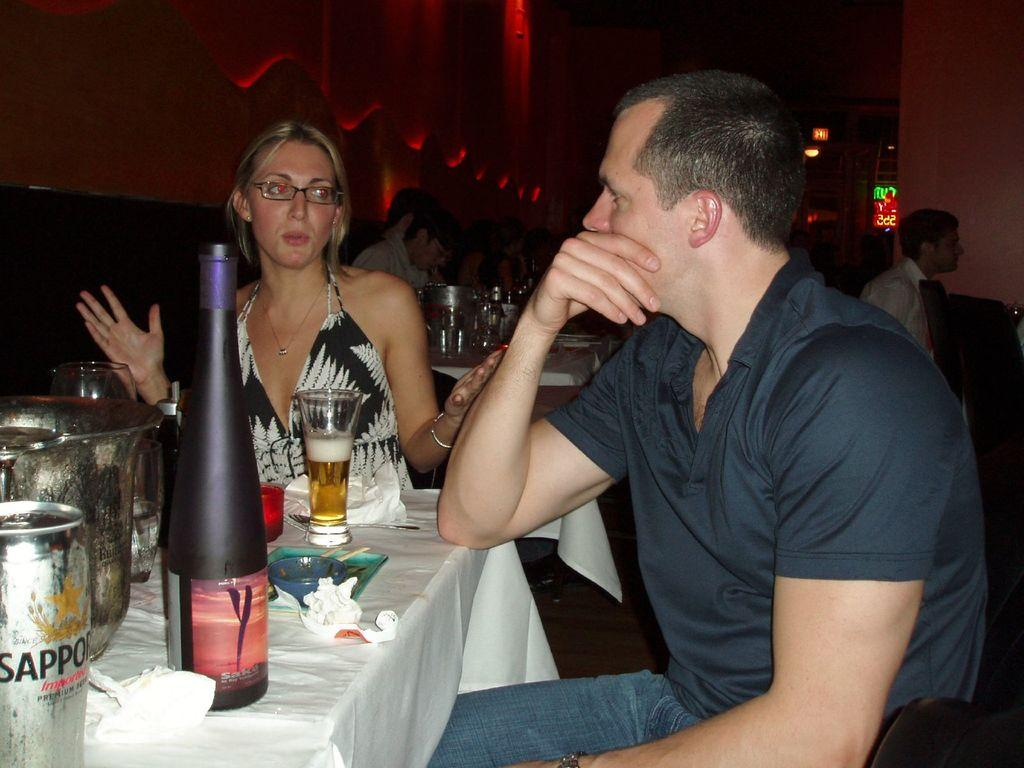<image>
Render a clear and concise summary of the photo. A can of Sapporo is on the table near a tall dark bottle. 